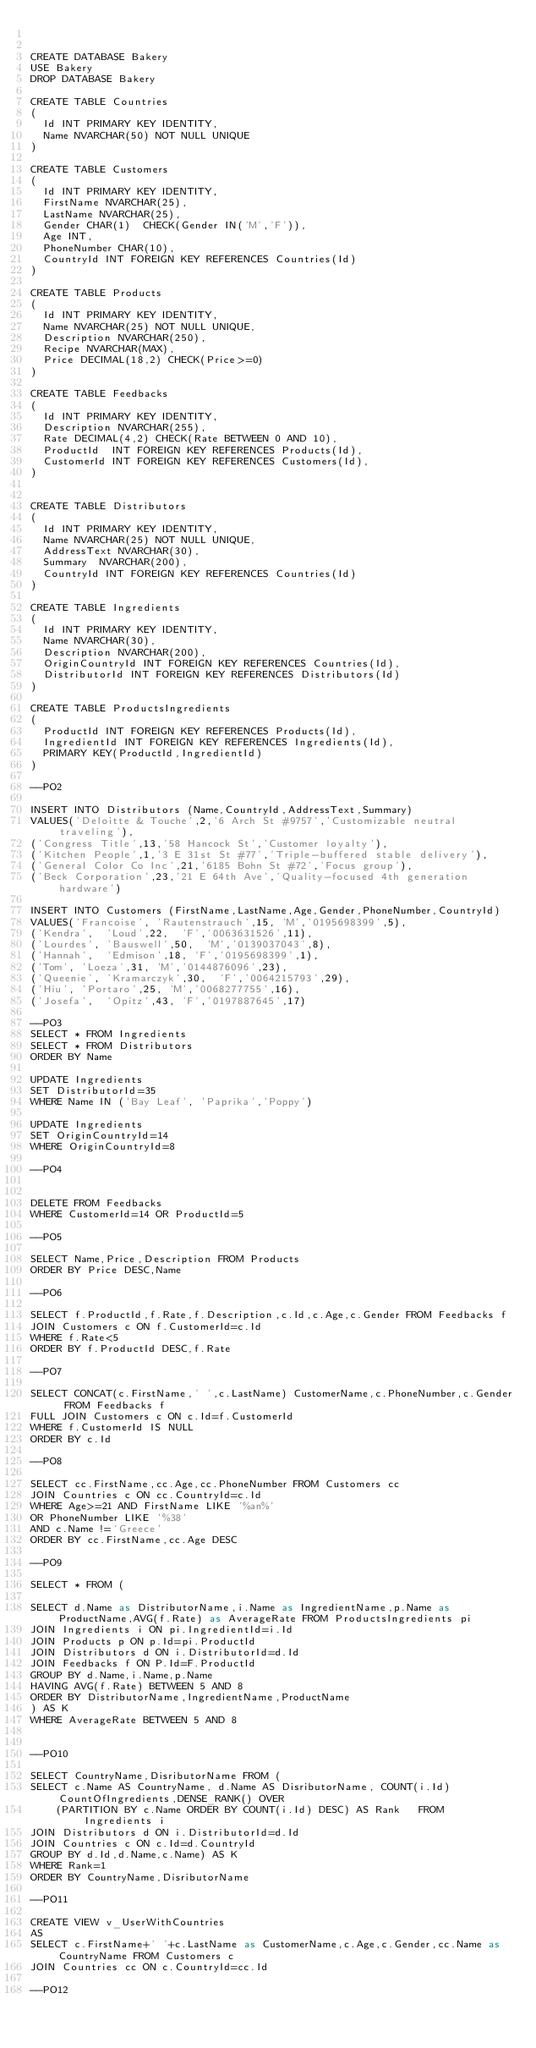Convert code to text. <code><loc_0><loc_0><loc_500><loc_500><_SQL_>

CREATE DATABASE Bakery
USE Bakery
DROP DATABASE Bakery

CREATE TABLE Countries
(
	Id INT PRIMARY KEY IDENTITY,
	Name NVARCHAR(50) NOT NULL UNIQUE
)

CREATE TABLE Customers
(
	Id INT PRIMARY KEY IDENTITY,
	FirstName NVARCHAR(25),
	LastName NVARCHAR(25),
	Gender CHAR(1)  CHECK(Gender IN('M','F')),
	Age INT,
	PhoneNumber CHAR(10),
	CountryId INT FOREIGN KEY REFERENCES Countries(Id)
)

CREATE TABLE Products
(
	Id INT PRIMARY KEY IDENTITY,
	Name NVARCHAR(25) NOT NULL UNIQUE,
	Description NVARCHAR(250),	
	Recipe NVARCHAR(MAX),	
	Price DECIMAL(18,2) CHECK(Price>=0)
)

CREATE TABLE Feedbacks
(
	Id INT PRIMARY KEY IDENTITY,
	Description NVARCHAR(255),
	Rate DECIMAL(4,2) CHECK(Rate BETWEEN 0 AND 10),
	ProductId  INT FOREIGN KEY REFERENCES Products(Id),
	CustomerId INT FOREIGN KEY REFERENCES Customers(Id),
)


CREATE TABLE Distributors
(
	Id INT PRIMARY KEY IDENTITY,
	Name NVARCHAR(25) NOT NULL UNIQUE,
	AddressText NVARCHAR(30),
	Summary	 NVARCHAR(200),
	CountryId INT FOREIGN KEY REFERENCES Countries(Id)
)

CREATE TABLE Ingredients
(
	Id INT PRIMARY KEY IDENTITY,
	Name NVARCHAR(30),
	Description NVARCHAR(200),
	OriginCountryId INT FOREIGN KEY REFERENCES Countries(Id),
	DistributorId INT FOREIGN KEY REFERENCES Distributors(Id)
)

CREATE TABLE ProductsIngredients
(
	ProductId INT FOREIGN KEY REFERENCES Products(Id),
	IngredientId INT FOREIGN KEY REFERENCES Ingredients(Id),
	PRIMARY KEY(ProductId,IngredientId)
)

--PO2

INSERT INTO Distributors (Name,CountryId,AddressText,Summary)
VALUES('Deloitte & Touche',2,'6 Arch St #9757','Customizable neutral traveling'),
('Congress Title',13,'58 Hancock St','Customer loyalty'),
('Kitchen People',1,'3 E 31st St #77','Triple-buffered stable delivery'),
('General Color Co Inc',21,'6185 Bohn St #72','Focus group'),
('Beck Corporation',23,'21 E 64th Ave','Quality-focused 4th generation hardware')

INSERT INTO Customers (FirstName,LastName,Age,Gender,PhoneNumber,CountryId)
VALUES('Francoise',	'Rautenstrauch',15,	'M','0195698399',5),
('Kendra',	'Loud',22,	'F','0063631526',11),
('Lourdes',	'Bauswell',50,	'M','0139037043',8),
('Hannah',	'Edmison',18,	'F','0195698399',1),
('Tom',	'Loeza',31,	'M','0144876096',23),
('Queenie',	'Kramarczyk',30,	'F','0064215793',29),
('Hiu',	'Portaro',25,	'M','0068277755',16),
('Josefa',	'Opitz',43,	'F','0197887645',17)

--PO3
SELECT * FROM Ingredients
SELECT * FROM Distributors
ORDER BY Name

UPDATE Ingredients
SET DistributorId=35
WHERE Name IN ('Bay Leaf', 'Paprika','Poppy')

UPDATE Ingredients
SET OriginCountryId=14
WHERE OriginCountryId=8

--PO4


DELETE FROM Feedbacks
WHERE CustomerId=14 OR ProductId=5

--PO5

SELECT Name,Price,Description FROM Products
ORDER BY Price DESC,Name

--PO6

SELECT f.ProductId,f.Rate,f.Description,c.Id,c.Age,c.Gender FROM Feedbacks f
JOIN Customers c ON f.CustomerId=c.Id
WHERE f.Rate<5
ORDER BY f.ProductId DESC,f.Rate

--PO7

SELECT CONCAT(c.FirstName,' ',c.LastName) CustomerName,c.PhoneNumber,c.Gender FROM Feedbacks f
FULL JOIN Customers c ON c.Id=f.CustomerId
WHERE f.CustomerId IS NULL
ORDER BY c.Id

--PO8

SELECT cc.FirstName,cc.Age,cc.PhoneNumber FROM Customers cc
JOIN Countries c ON cc.CountryId=c.Id
WHERE Age>=21 AND FirstName LIKE '%an%'
OR PhoneNumber LIKE '%38'
AND c.Name !='Greece'
ORDER BY cc.FirstName,cc.Age DESC

--PO9

SELECT * FROM (

SELECT d.Name as DistributorName,i.Name as IngredientName,p.Name as ProductName,AVG(f.Rate) as AverageRate FROM ProductsIngredients pi
JOIN Ingredients i ON pi.IngredientId=i.Id
JOIN Products p ON p.Id=pi.ProductId
JOIN Distributors d ON i.DistributorId=d.Id
JOIN Feedbacks f ON P.Id=F.ProductId
GROUP BY d.Name,i.Name,p.Name
HAVING AVG(f.Rate) BETWEEN 5 AND 8
ORDER BY DistributorName,IngredientName,ProductName
) AS K
WHERE AverageRate BETWEEN 5 AND 8


--PO10

SELECT CountryName,DisributorName FROM (
SELECT c.Name AS CountryName, d.Name AS DisributorName, COUNT(i.Id) CountOfIngredients,DENSE_RANK() OVER   
    (PARTITION BY c.Name ORDER BY COUNT(i.Id) DESC) AS Rank   FROM Ingredients i
JOIN Distributors d ON i.DistributorId=d.Id
JOIN Countries c ON c.Id=d.CountryId
GROUP BY d.Id,d.Name,c.Name) AS K
WHERE Rank=1
ORDER BY CountryName,DisributorName

--PO11

CREATE VIEW v_UserWithCountries 
AS
SELECT c.FirstName+' '+c.LastName as CustomerName,c.Age,c.Gender,cc.Name as CountryName FROM Customers c
JOIN Countries cc ON c.CountryId=cc.Id

--PO12



</code> 